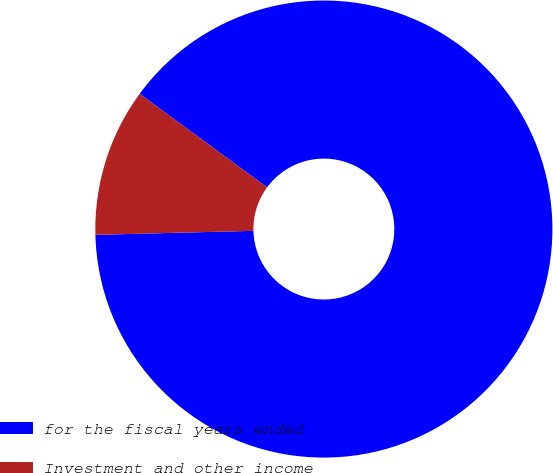Convert chart to OTSL. <chart><loc_0><loc_0><loc_500><loc_500><pie_chart><fcel>for the fiscal years ended<fcel>Investment and other income<nl><fcel>89.52%<fcel>10.48%<nl></chart> 